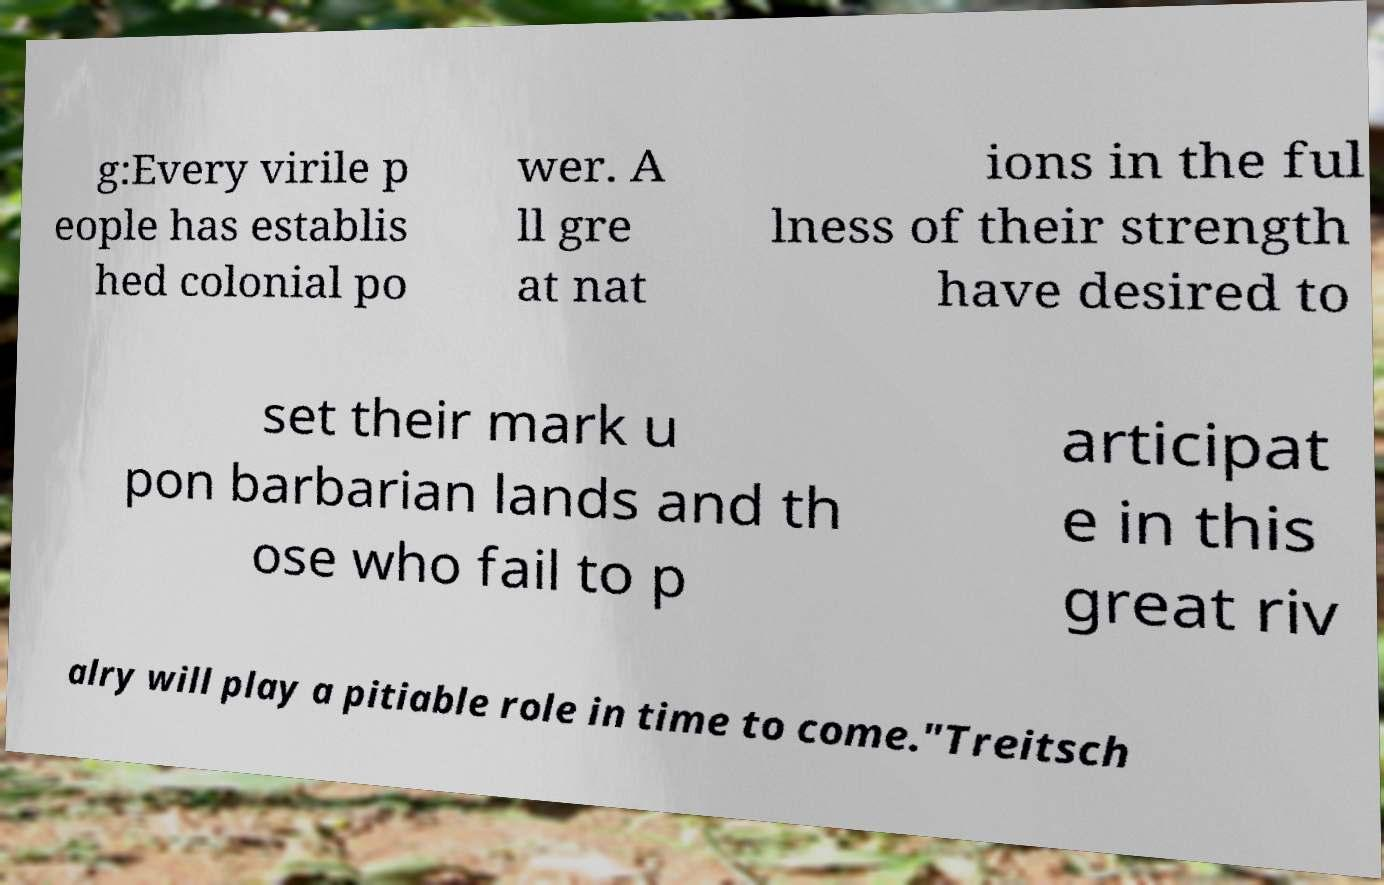Could you assist in decoding the text presented in this image and type it out clearly? g:Every virile p eople has establis hed colonial po wer. A ll gre at nat ions in the ful lness of their strength have desired to set their mark u pon barbarian lands and th ose who fail to p articipat e in this great riv alry will play a pitiable role in time to come."Treitsch 